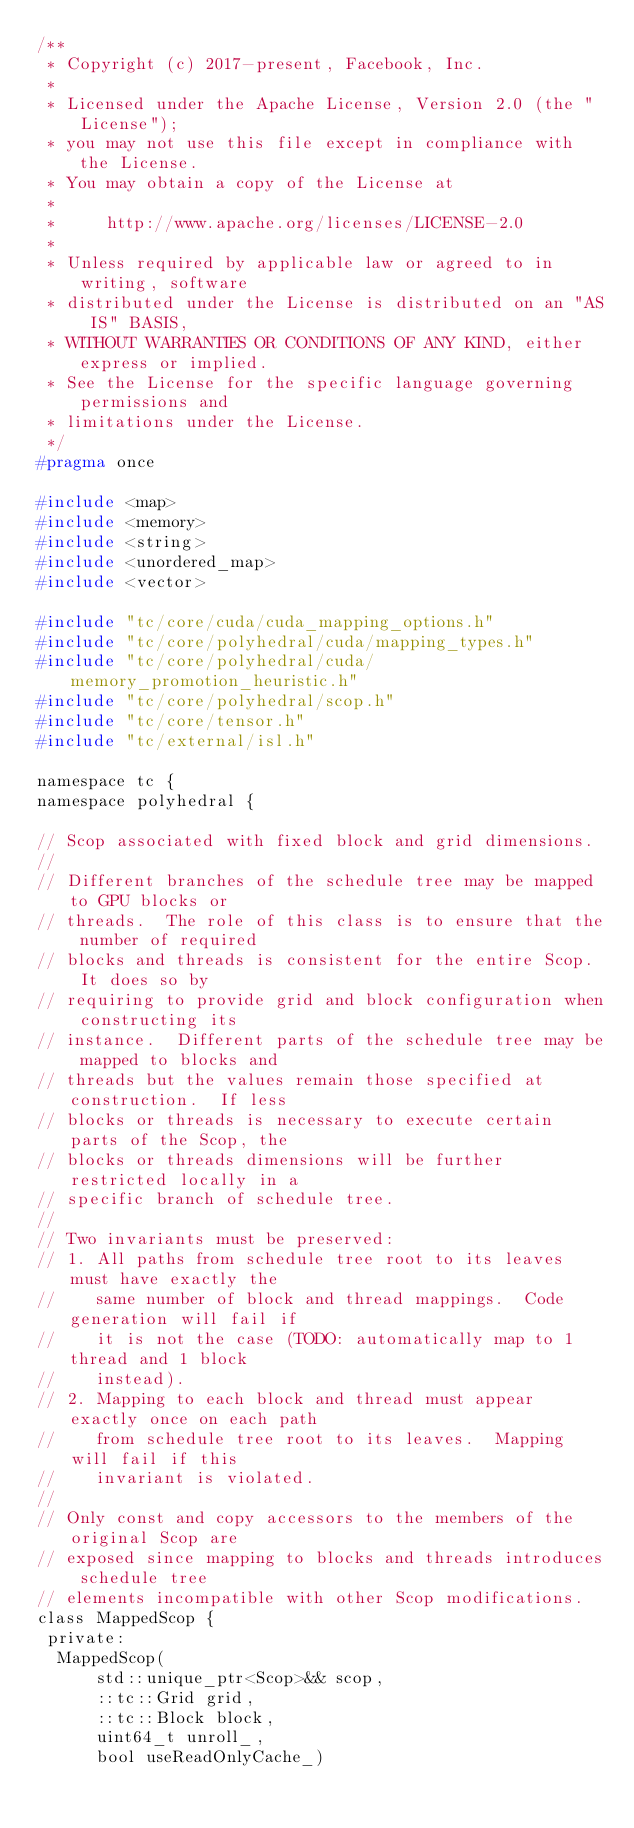<code> <loc_0><loc_0><loc_500><loc_500><_C_>/**
 * Copyright (c) 2017-present, Facebook, Inc.
 *
 * Licensed under the Apache License, Version 2.0 (the "License");
 * you may not use this file except in compliance with the License.
 * You may obtain a copy of the License at
 *
 *     http://www.apache.org/licenses/LICENSE-2.0
 *
 * Unless required by applicable law or agreed to in writing, software
 * distributed under the License is distributed on an "AS IS" BASIS,
 * WITHOUT WARRANTIES OR CONDITIONS OF ANY KIND, either express or implied.
 * See the License for the specific language governing permissions and
 * limitations under the License.
 */
#pragma once

#include <map>
#include <memory>
#include <string>
#include <unordered_map>
#include <vector>

#include "tc/core/cuda/cuda_mapping_options.h"
#include "tc/core/polyhedral/cuda/mapping_types.h"
#include "tc/core/polyhedral/cuda/memory_promotion_heuristic.h"
#include "tc/core/polyhedral/scop.h"
#include "tc/core/tensor.h"
#include "tc/external/isl.h"

namespace tc {
namespace polyhedral {

// Scop associated with fixed block and grid dimensions.
//
// Different branches of the schedule tree may be mapped to GPU blocks or
// threads.  The role of this class is to ensure that the number of required
// blocks and threads is consistent for the entire Scop.  It does so by
// requiring to provide grid and block configuration when constructing its
// instance.  Different parts of the schedule tree may be mapped to blocks and
// threads but the values remain those specified at construction.  If less
// blocks or threads is necessary to execute certain parts of the Scop, the
// blocks or threads dimensions will be further restricted locally in a
// specific branch of schedule tree.
//
// Two invariants must be preserved:
// 1. All paths from schedule tree root to its leaves must have exactly the
//    same number of block and thread mappings.  Code generation will fail if
//    it is not the case (TODO: automatically map to 1 thread and 1 block
//    instead).
// 2. Mapping to each block and thread must appear exactly once on each path
//    from schedule tree root to its leaves.  Mapping will fail if this
//    invariant is violated.
//
// Only const and copy accessors to the members of the original Scop are
// exposed since mapping to blocks and threads introduces schedule tree
// elements incompatible with other Scop modifications.
class MappedScop {
 private:
  MappedScop(
      std::unique_ptr<Scop>&& scop,
      ::tc::Grid grid,
      ::tc::Block block,
      uint64_t unroll_,
      bool useReadOnlyCache_)</code> 